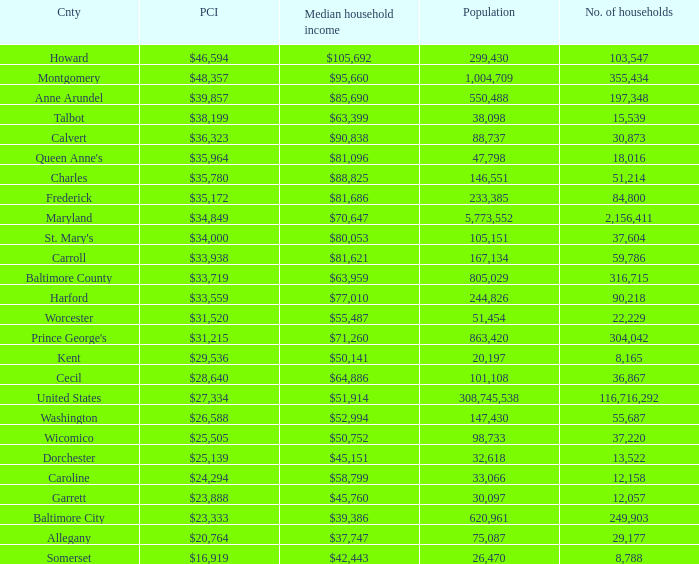What is the per capital income for Washington county? $26,588. Could you help me parse every detail presented in this table? {'header': ['Cnty', 'PCI', 'Median household income', 'Population', 'No. of households'], 'rows': [['Howard', '$46,594', '$105,692', '299,430', '103,547'], ['Montgomery', '$48,357', '$95,660', '1,004,709', '355,434'], ['Anne Arundel', '$39,857', '$85,690', '550,488', '197,348'], ['Talbot', '$38,199', '$63,399', '38,098', '15,539'], ['Calvert', '$36,323', '$90,838', '88,737', '30,873'], ["Queen Anne's", '$35,964', '$81,096', '47,798', '18,016'], ['Charles', '$35,780', '$88,825', '146,551', '51,214'], ['Frederick', '$35,172', '$81,686', '233,385', '84,800'], ['Maryland', '$34,849', '$70,647', '5,773,552', '2,156,411'], ["St. Mary's", '$34,000', '$80,053', '105,151', '37,604'], ['Carroll', '$33,938', '$81,621', '167,134', '59,786'], ['Baltimore County', '$33,719', '$63,959', '805,029', '316,715'], ['Harford', '$33,559', '$77,010', '244,826', '90,218'], ['Worcester', '$31,520', '$55,487', '51,454', '22,229'], ["Prince George's", '$31,215', '$71,260', '863,420', '304,042'], ['Kent', '$29,536', '$50,141', '20,197', '8,165'], ['Cecil', '$28,640', '$64,886', '101,108', '36,867'], ['United States', '$27,334', '$51,914', '308,745,538', '116,716,292'], ['Washington', '$26,588', '$52,994', '147,430', '55,687'], ['Wicomico', '$25,505', '$50,752', '98,733', '37,220'], ['Dorchester', '$25,139', '$45,151', '32,618', '13,522'], ['Caroline', '$24,294', '$58,799', '33,066', '12,158'], ['Garrett', '$23,888', '$45,760', '30,097', '12,057'], ['Baltimore City', '$23,333', '$39,386', '620,961', '249,903'], ['Allegany', '$20,764', '$37,747', '75,087', '29,177'], ['Somerset', '$16,919', '$42,443', '26,470', '8,788']]} 